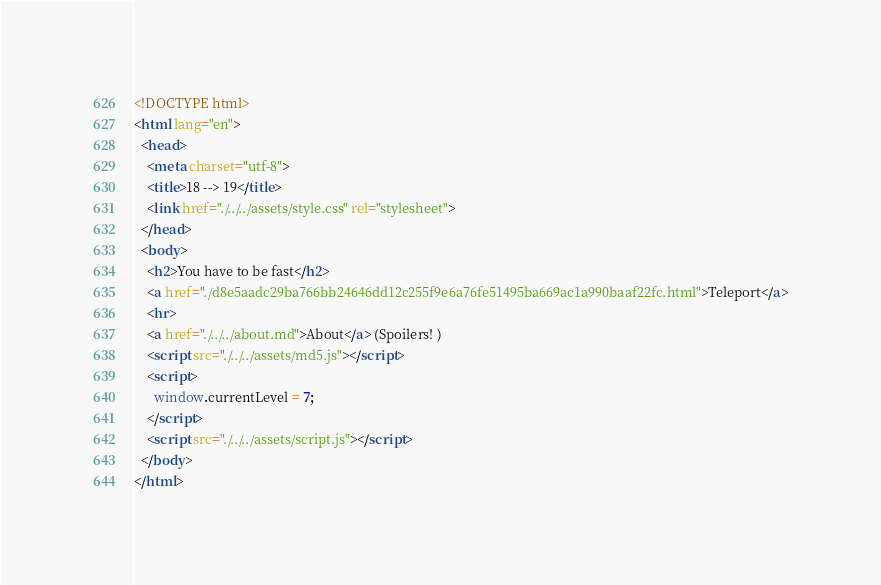Convert code to text. <code><loc_0><loc_0><loc_500><loc_500><_HTML_><!DOCTYPE html>
<html lang="en">
  <head>
    <meta charset="utf-8">
    <title>18 --> 19</title>
    <link href="./../../assets/style.css" rel="stylesheet">
  </head>
  <body>
    <h2>You have to be fast</h2>
    <a href="./d8e5aadc29ba766bb24646dd12c255f9e6a76fe51495ba669ac1a990baaf22fc.html">Teleport</a>
    <hr>
    <a href="./../../about.md">About</a> (Spoilers! )
    <script src="./../../assets/md5.js"></script>
    <script>
      window.currentLevel = 7;
    </script>
    <script src="./../../assets/script.js"></script>
  </body>
</html></code> 